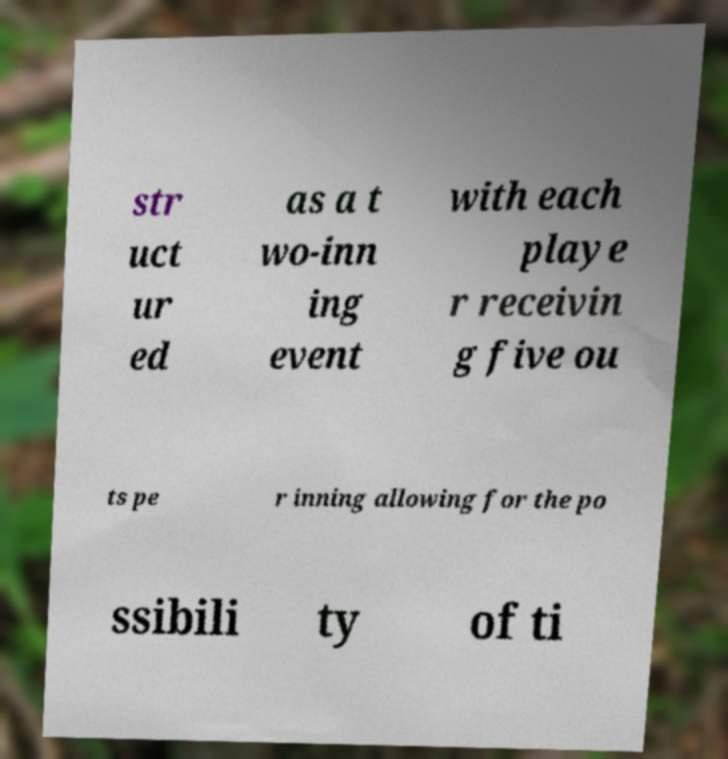There's text embedded in this image that I need extracted. Can you transcribe it verbatim? str uct ur ed as a t wo-inn ing event with each playe r receivin g five ou ts pe r inning allowing for the po ssibili ty of ti 